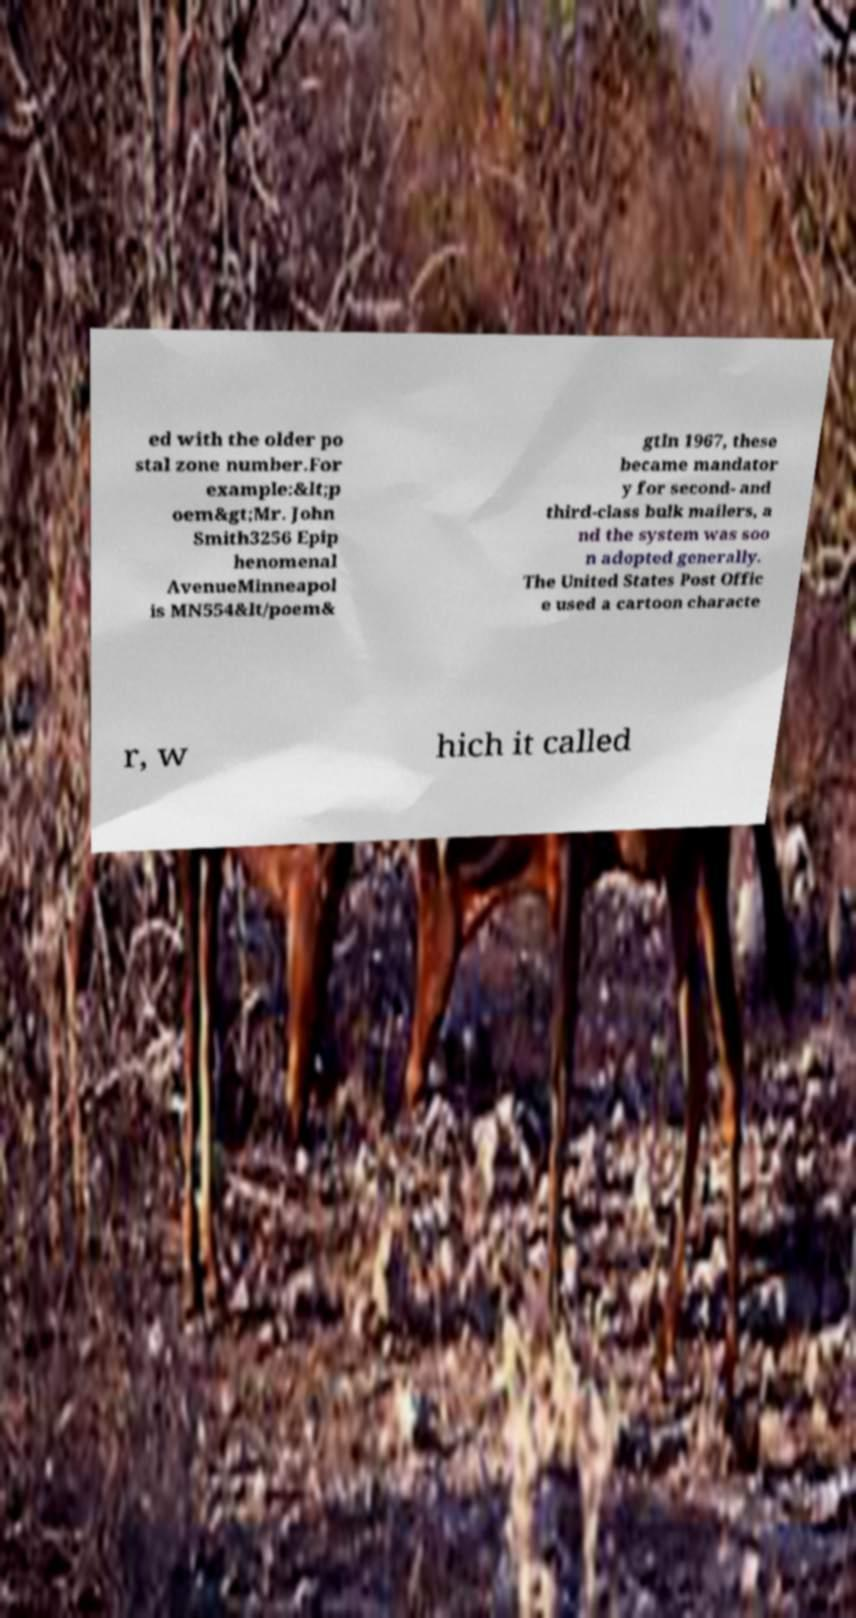Please identify and transcribe the text found in this image. ed with the older po stal zone number.For example:&lt;p oem&gt;Mr. John Smith3256 Epip henomenal AvenueMinneapol is MN554&lt/poem& gtIn 1967, these became mandator y for second- and third-class bulk mailers, a nd the system was soo n adopted generally. The United States Post Offic e used a cartoon characte r, w hich it called 